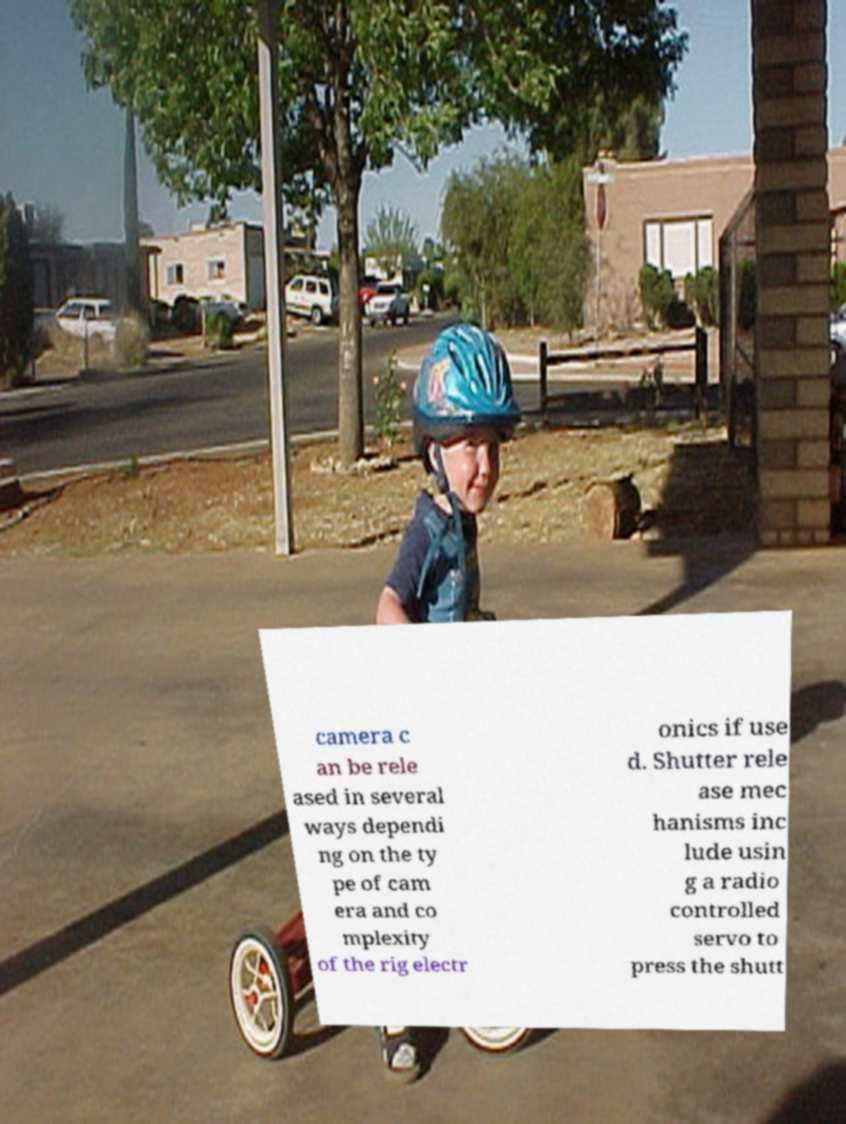I need the written content from this picture converted into text. Can you do that? camera c an be rele ased in several ways dependi ng on the ty pe of cam era and co mplexity of the rig electr onics if use d. Shutter rele ase mec hanisms inc lude usin g a radio controlled servo to press the shutt 